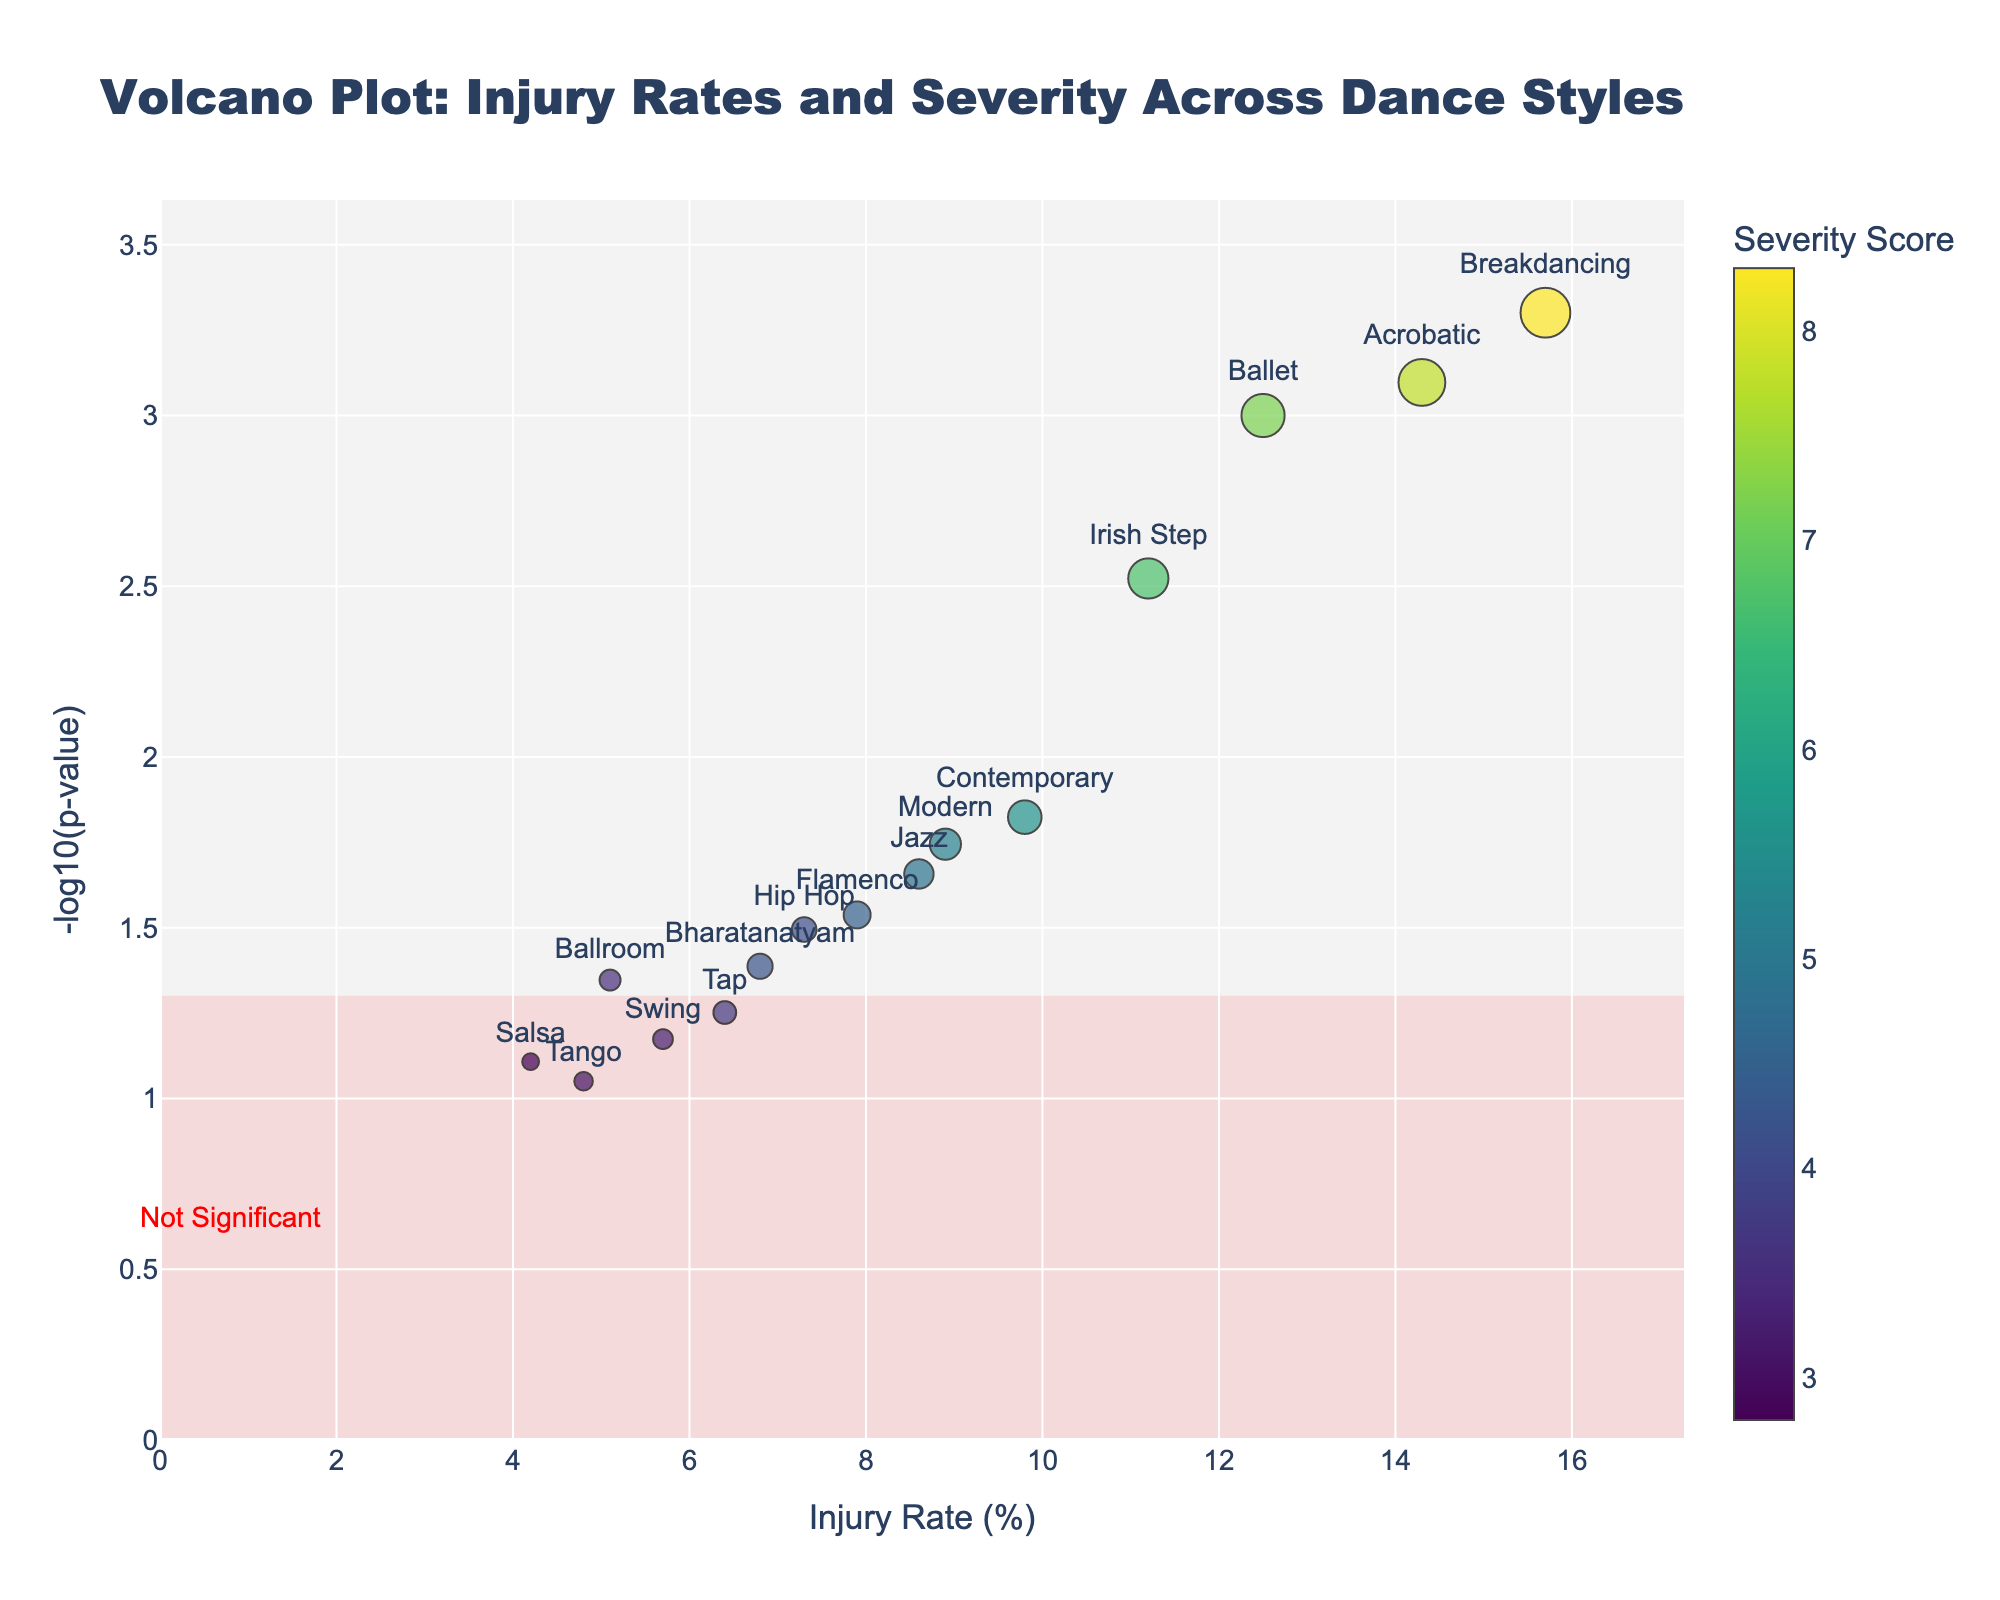What is the title of the figure? The title is displayed prominently at the top of the figure. By reading it, you can identify the content or subject of the plot.
Answer: Volcano Plot: Injury Rates and Severity Across Dance Styles How many dance styles are analyzed in the figure? Count the number of labeled points in the plot. Each point represents a different dance style.
Answer: 15 Which dance style has the highest injury rate? Look at the X-axis which represents the injury rate (%), find the data point with the highest value on this axis.
Answer: Breakdancing What does the color of the markers represent? Check the color bar on the right side of the plot, it describes that colors correspond to the Severity Score values.
Answer: Severity Score What is the significance threshold for p-values in the figure? Observe the horizontal shaded region and associated annotations, which indicate the significance threshold. The significance threshold typically corresponds to a p-value of 0.05.
Answer: p-value of 0.05 Which dance style has the highest severity score? Refer to the color intensity of the markers, or use the mouse over tooltip to check Severity Score values.
Answer: Breakdancing How are markers' sizes determined in the figure? Look at the marker size descriptions, which are scaled according to the Severity Score. Larger circles represent higher Severity Scores.
Answer: By Severity Score, scaled by a factor of 3 Which data points fall into the "Not Significant" region? Identify points below the horizontal line corresponding to -log10(p-value)=1.3 (since -log10(0.05)≈1.3), which means their p-value is greater than 0.05.
Answer: Salsa, Tap, Swing, Tango Compare the injury rate and severity score of Ballet and Acrobatic dance styles. Which has a higher injury rate, and which has a higher severity score? Look at both Ballet and Acrobatic points on the plot, compare their X-axis values for injury rates and their colors (or hover over to see Severity Scores).
Answer: Acrobatic has a higher injury rate; Breakdancing has a higher severity score What is the position of Contemporary dance on the plot relative to Hip Hop dance based on injury rates and significance? Locate both Contemporary and Hip Hop data points on the plot, compare their positions on both the X-axis (injury rate) and Y-axis (-log10(p-value)).
Answer: Contemporary has a higher injury rate and is more significant than Hip Hop 